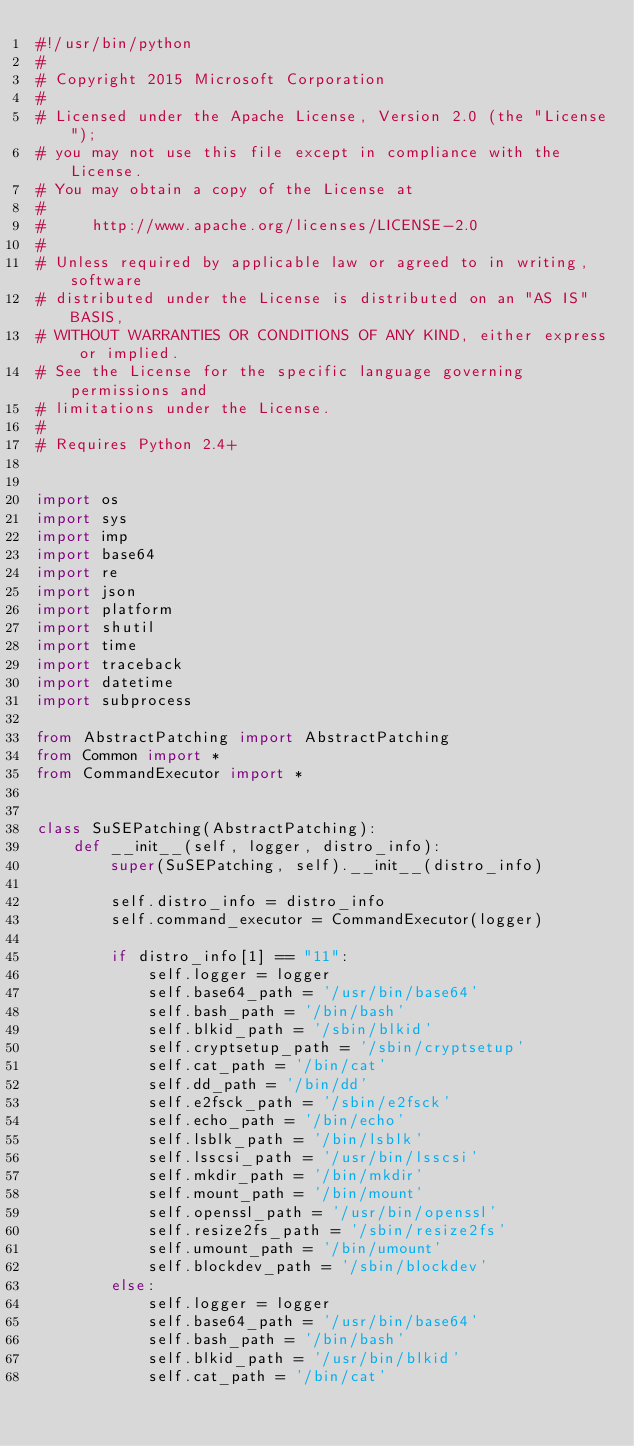Convert code to text. <code><loc_0><loc_0><loc_500><loc_500><_Python_>#!/usr/bin/python
#
# Copyright 2015 Microsoft Corporation
#
# Licensed under the Apache License, Version 2.0 (the "License");
# you may not use this file except in compliance with the License.
# You may obtain a copy of the License at
#
#     http://www.apache.org/licenses/LICENSE-2.0
#
# Unless required by applicable law or agreed to in writing, software
# distributed under the License is distributed on an "AS IS" BASIS,
# WITHOUT WARRANTIES OR CONDITIONS OF ANY KIND, either express or implied.
# See the License for the specific language governing permissions and
# limitations under the License.
#
# Requires Python 2.4+


import os
import sys
import imp
import base64
import re
import json
import platform
import shutil
import time
import traceback
import datetime
import subprocess

from AbstractPatching import AbstractPatching
from Common import *
from CommandExecutor import *


class SuSEPatching(AbstractPatching):
    def __init__(self, logger, distro_info):
        super(SuSEPatching, self).__init__(distro_info)

        self.distro_info = distro_info
        self.command_executor = CommandExecutor(logger)

        if distro_info[1] == "11":
            self.logger = logger
            self.base64_path = '/usr/bin/base64'
            self.bash_path = '/bin/bash'
            self.blkid_path = '/sbin/blkid'
            self.cryptsetup_path = '/sbin/cryptsetup'
            self.cat_path = '/bin/cat'
            self.dd_path = '/bin/dd'
            self.e2fsck_path = '/sbin/e2fsck'
            self.echo_path = '/bin/echo'
            self.lsblk_path = '/bin/lsblk'
            self.lsscsi_path = '/usr/bin/lsscsi'
            self.mkdir_path = '/bin/mkdir'
            self.mount_path = '/bin/mount'
            self.openssl_path = '/usr/bin/openssl'
            self.resize2fs_path = '/sbin/resize2fs'
            self.umount_path = '/bin/umount'
            self.blockdev_path = '/sbin/blockdev'
        else:
            self.logger = logger
            self.base64_path = '/usr/bin/base64'
            self.bash_path = '/bin/bash'
            self.blkid_path = '/usr/bin/blkid'
            self.cat_path = '/bin/cat'</code> 